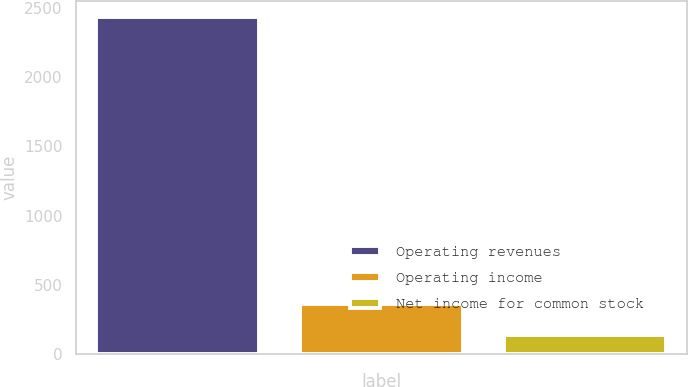Convert chart. <chart><loc_0><loc_0><loc_500><loc_500><bar_chart><fcel>Operating revenues<fcel>Operating income<fcel>Net income for common stock<nl><fcel>2432<fcel>364.7<fcel>135<nl></chart> 